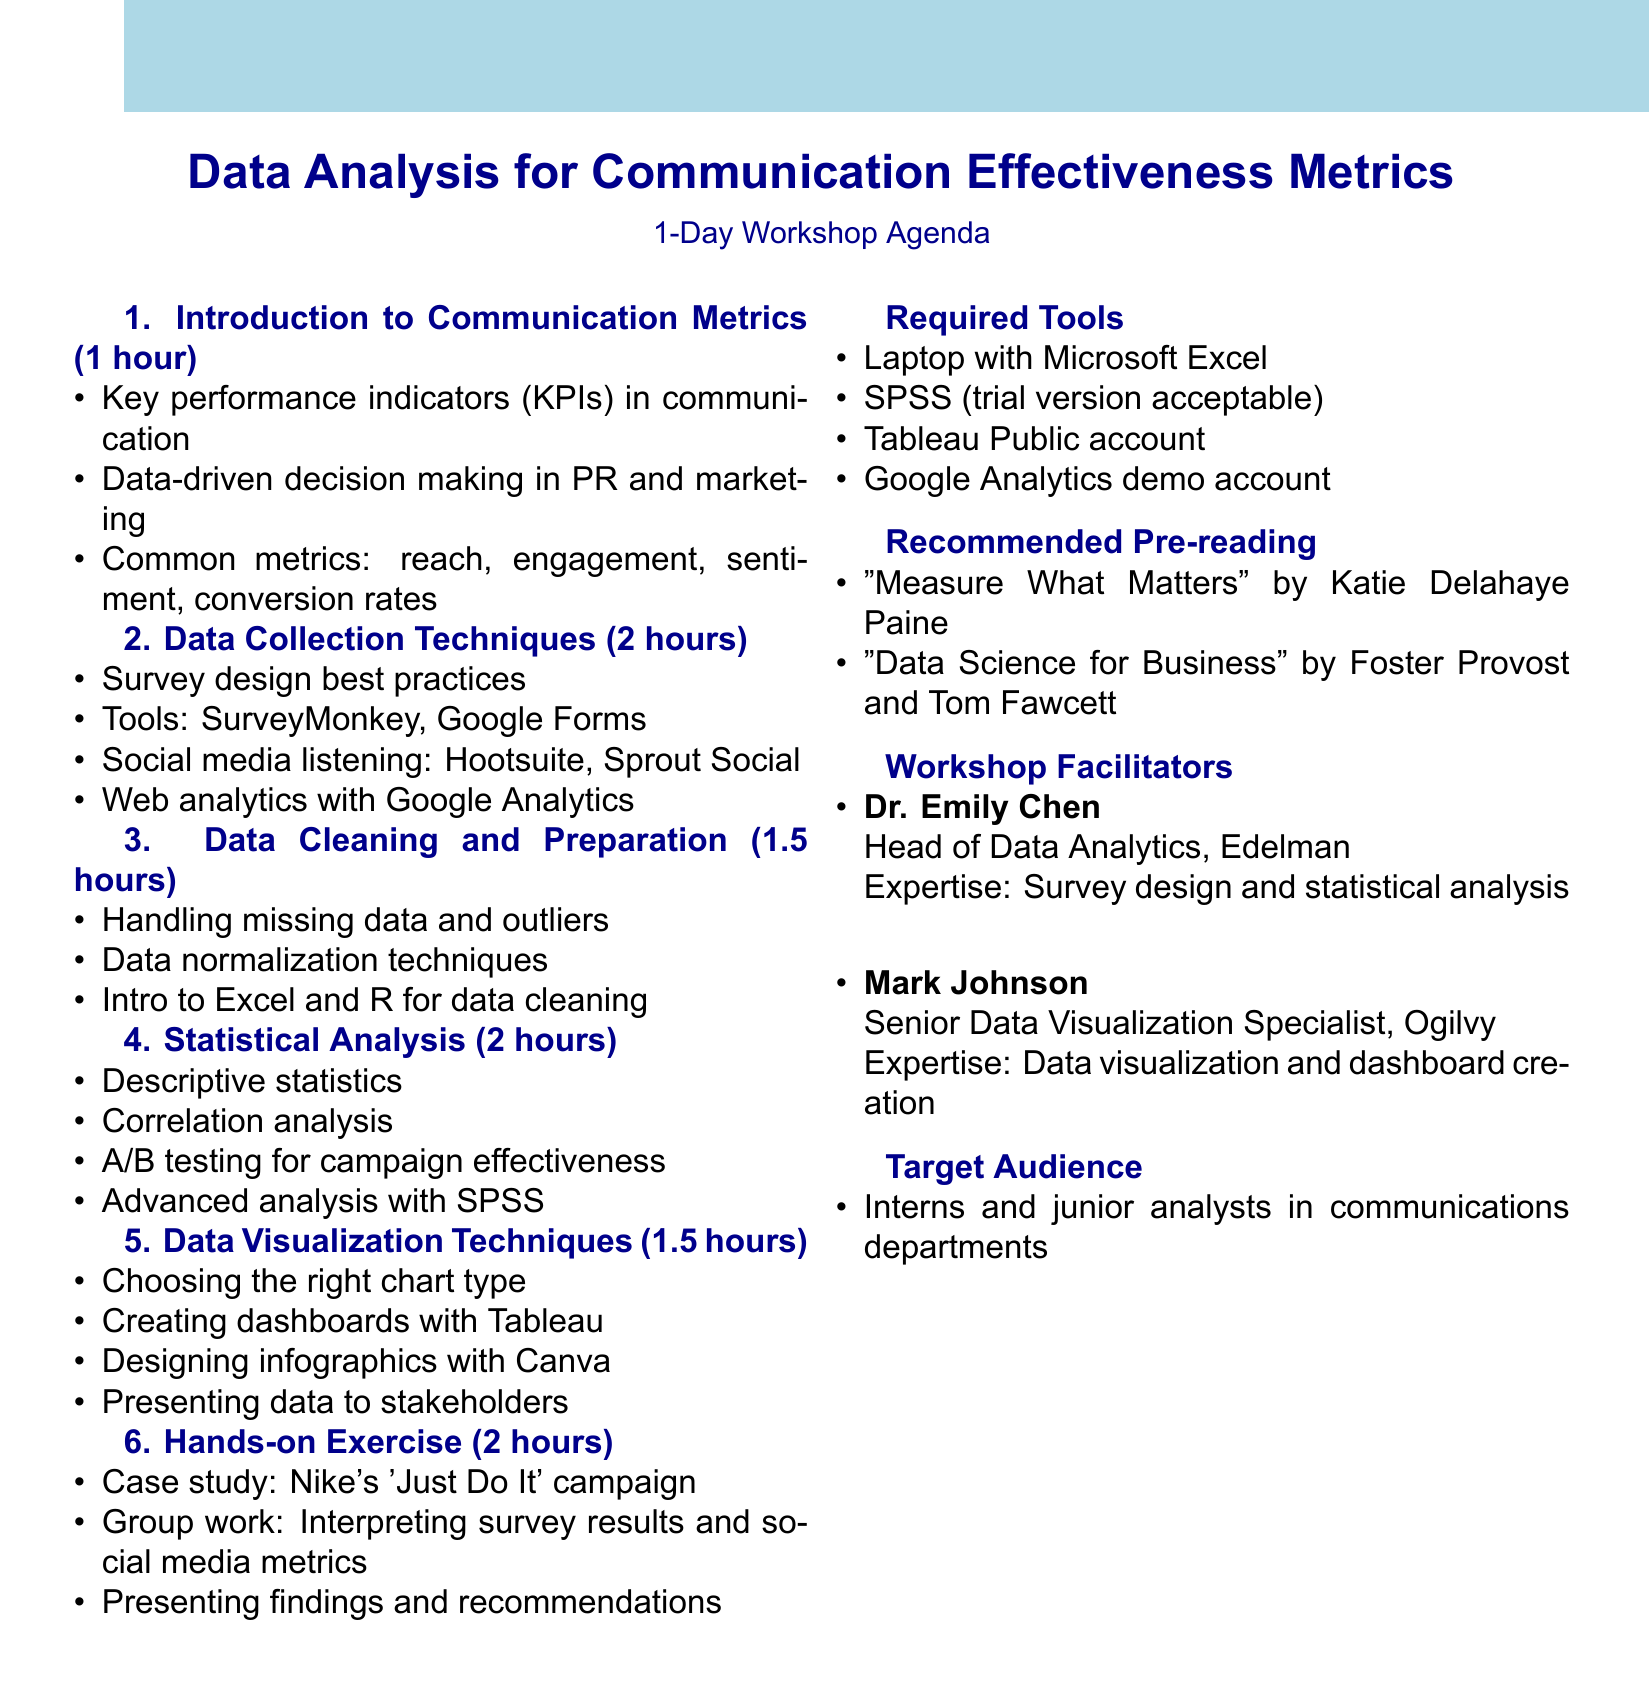What is the workshop title? The title of the workshop is usually stated at the top of the agenda.
Answer: Data Analysis for Communication Effectiveness Metrics How long is the workshop? The duration is mentioned in the overview section of the agenda.
Answer: 1 day (8 hours) Who is the target audience for the workshop? The target audience is specified in the document to identify who the workshop is designed for.
Answer: Interns and junior analysts in communications departments What is covered in the "Data Cleaning and Preparation" section? The topics to be covered in each section are listed and provide insight into what will be taught.
Answer: Identifying and handling missing data, Dealing with outliers and anomalies, Data normalization techniques, Introduction to Excel and R for data cleaning How many facilitators are there? The number of facilitators is provided in the section detailing the workshop facilitators.
Answer: 2 What type of tools are required for the workshop? The required tools are explicitly listed, indicating what participants need to bring.
Answer: Laptop with Microsoft Excel installed Which book is recommended for pre-reading? The recommended pre-reading section mentions suggested books for participants to review beforehand.
Answer: "Measure What Matters" by Katie Delahaye Paine What is one of the topics discussed in the "Statistical Analysis" section? Each section has its own topics, which give an idea of what to expect in the workshop.
Answer: Correlation analysis for identifying relationships between variables What type of exercise concludes the workshop? The exercise type is indicated in the agenda to highlight the hands-on aspect.
Answer: Analyzing a Real-world Communication Campaign 